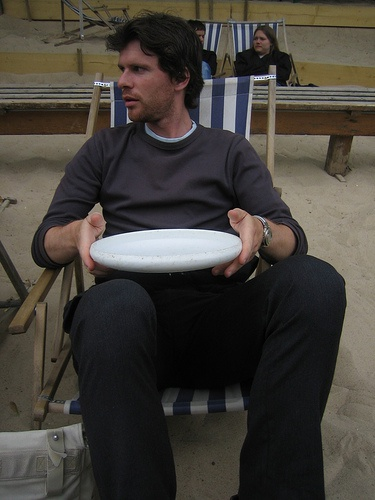Describe the objects in this image and their specific colors. I can see people in black, gray, and lightgray tones, chair in black, gray, and darkgray tones, handbag in black and gray tones, frisbee in black, lightgray, darkgray, and gray tones, and people in black and gray tones in this image. 